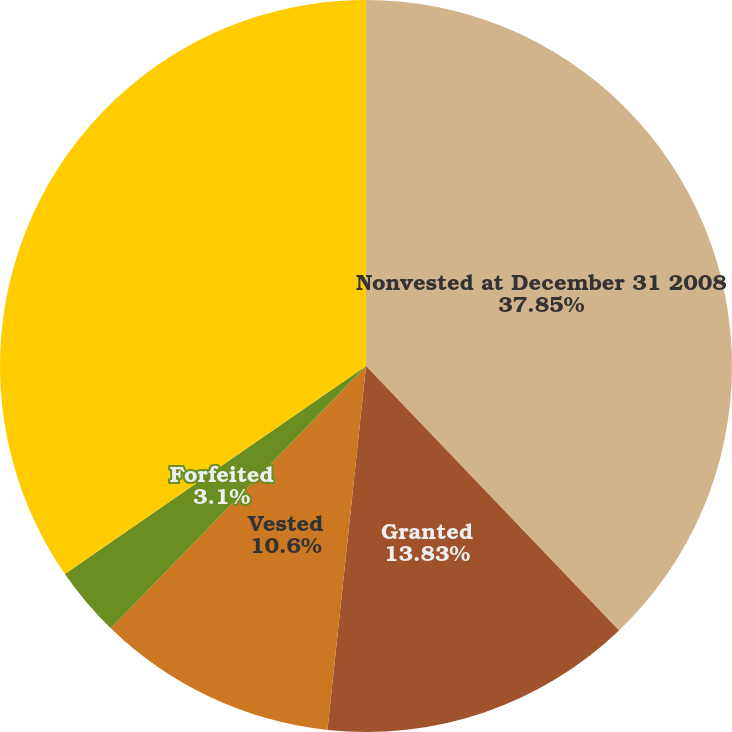Convert chart to OTSL. <chart><loc_0><loc_0><loc_500><loc_500><pie_chart><fcel>Nonvested at December 31 2008<fcel>Granted<fcel>Vested<fcel>Forfeited<fcel>Nonvested at December 31 2009<nl><fcel>37.85%<fcel>13.83%<fcel>10.6%<fcel>3.1%<fcel>34.62%<nl></chart> 